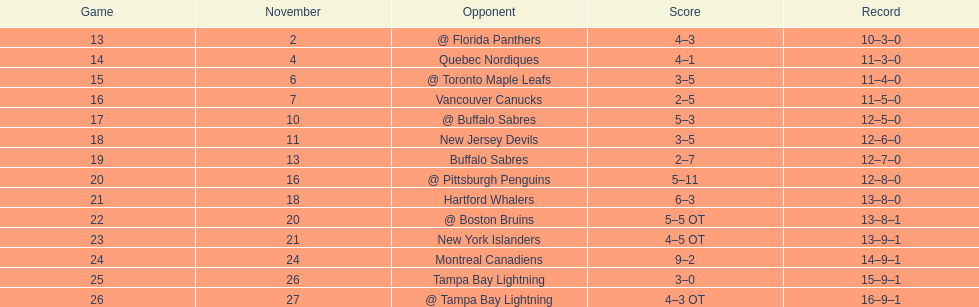What was the number of wins the philadelphia flyers had? 35. 